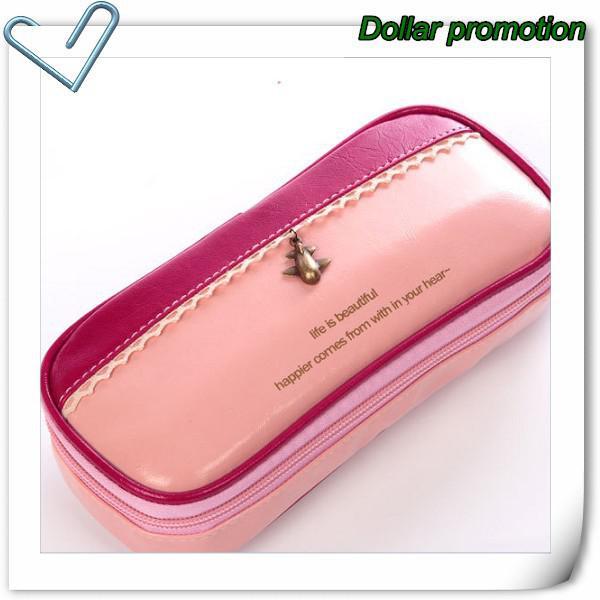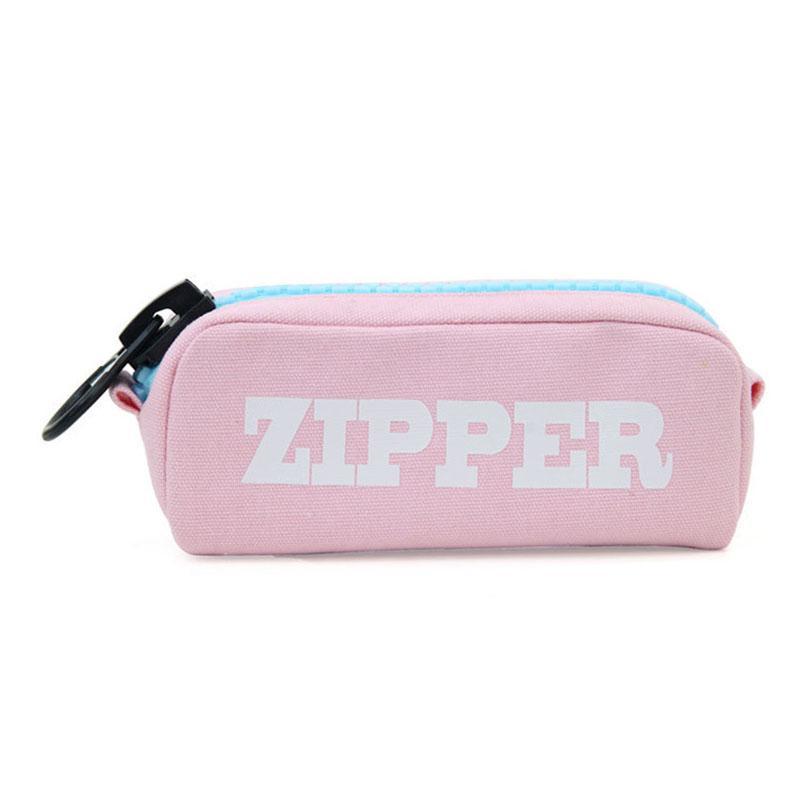The first image is the image on the left, the second image is the image on the right. Evaluate the accuracy of this statement regarding the images: "The image on the right has a double zipper.". Is it true? Answer yes or no. No. The first image is the image on the left, the second image is the image on the right. Analyze the images presented: Is the assertion "the right image has a pencil pouch with 2 front pockets and two zippers on top" valid? Answer yes or no. No. 